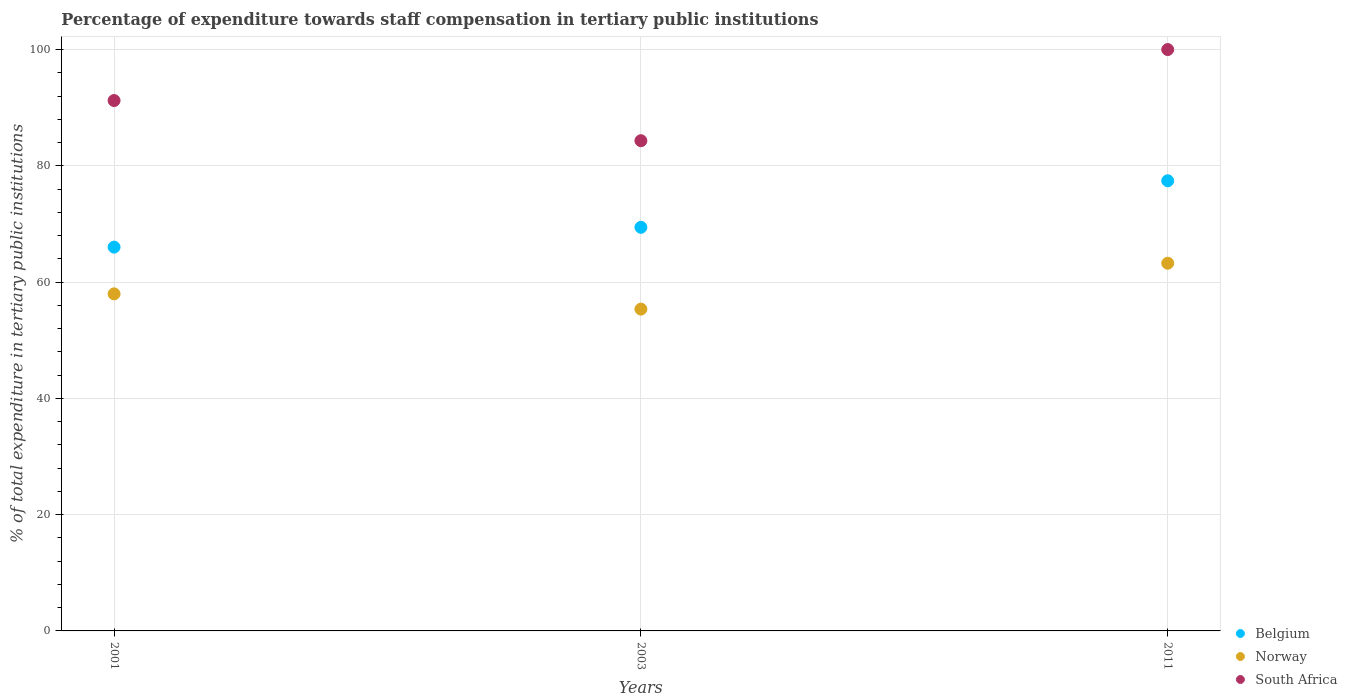How many different coloured dotlines are there?
Ensure brevity in your answer.  3. Is the number of dotlines equal to the number of legend labels?
Offer a terse response. Yes. What is the percentage of expenditure towards staff compensation in South Africa in 2003?
Give a very brief answer. 84.32. Across all years, what is the maximum percentage of expenditure towards staff compensation in Norway?
Your answer should be very brief. 63.25. Across all years, what is the minimum percentage of expenditure towards staff compensation in Belgium?
Make the answer very short. 66.02. In which year was the percentage of expenditure towards staff compensation in Belgium maximum?
Make the answer very short. 2011. What is the total percentage of expenditure towards staff compensation in Norway in the graph?
Make the answer very short. 176.58. What is the difference between the percentage of expenditure towards staff compensation in Norway in 2001 and that in 2003?
Give a very brief answer. 2.62. What is the difference between the percentage of expenditure towards staff compensation in South Africa in 2003 and the percentage of expenditure towards staff compensation in Belgium in 2001?
Ensure brevity in your answer.  18.3. What is the average percentage of expenditure towards staff compensation in South Africa per year?
Keep it short and to the point. 91.85. In the year 2001, what is the difference between the percentage of expenditure towards staff compensation in Norway and percentage of expenditure towards staff compensation in South Africa?
Offer a very short reply. -33.26. In how many years, is the percentage of expenditure towards staff compensation in Belgium greater than 96 %?
Your answer should be compact. 0. What is the ratio of the percentage of expenditure towards staff compensation in South Africa in 2003 to that in 2011?
Your answer should be very brief. 0.84. What is the difference between the highest and the second highest percentage of expenditure towards staff compensation in South Africa?
Keep it short and to the point. 8.77. What is the difference between the highest and the lowest percentage of expenditure towards staff compensation in Belgium?
Provide a succinct answer. 11.41. In how many years, is the percentage of expenditure towards staff compensation in South Africa greater than the average percentage of expenditure towards staff compensation in South Africa taken over all years?
Ensure brevity in your answer.  1. Is the sum of the percentage of expenditure towards staff compensation in Norway in 2001 and 2003 greater than the maximum percentage of expenditure towards staff compensation in South Africa across all years?
Give a very brief answer. Yes. Does the percentage of expenditure towards staff compensation in Belgium monotonically increase over the years?
Make the answer very short. Yes. Is the percentage of expenditure towards staff compensation in Belgium strictly greater than the percentage of expenditure towards staff compensation in Norway over the years?
Provide a succinct answer. Yes. How many years are there in the graph?
Keep it short and to the point. 3. What is the difference between two consecutive major ticks on the Y-axis?
Make the answer very short. 20. Does the graph contain any zero values?
Your answer should be very brief. No. Does the graph contain grids?
Make the answer very short. Yes. What is the title of the graph?
Keep it short and to the point. Percentage of expenditure towards staff compensation in tertiary public institutions. Does "Tajikistan" appear as one of the legend labels in the graph?
Offer a terse response. No. What is the label or title of the Y-axis?
Offer a terse response. % of total expenditure in tertiary public institutions. What is the % of total expenditure in tertiary public institutions in Belgium in 2001?
Offer a terse response. 66.02. What is the % of total expenditure in tertiary public institutions of Norway in 2001?
Your response must be concise. 57.97. What is the % of total expenditure in tertiary public institutions of South Africa in 2001?
Provide a short and direct response. 91.23. What is the % of total expenditure in tertiary public institutions of Belgium in 2003?
Your answer should be very brief. 69.43. What is the % of total expenditure in tertiary public institutions of Norway in 2003?
Give a very brief answer. 55.36. What is the % of total expenditure in tertiary public institutions in South Africa in 2003?
Your answer should be compact. 84.32. What is the % of total expenditure in tertiary public institutions of Belgium in 2011?
Ensure brevity in your answer.  77.43. What is the % of total expenditure in tertiary public institutions of Norway in 2011?
Give a very brief answer. 63.25. Across all years, what is the maximum % of total expenditure in tertiary public institutions in Belgium?
Offer a terse response. 77.43. Across all years, what is the maximum % of total expenditure in tertiary public institutions in Norway?
Ensure brevity in your answer.  63.25. Across all years, what is the maximum % of total expenditure in tertiary public institutions of South Africa?
Keep it short and to the point. 100. Across all years, what is the minimum % of total expenditure in tertiary public institutions of Belgium?
Your answer should be very brief. 66.02. Across all years, what is the minimum % of total expenditure in tertiary public institutions in Norway?
Provide a succinct answer. 55.36. Across all years, what is the minimum % of total expenditure in tertiary public institutions of South Africa?
Provide a succinct answer. 84.32. What is the total % of total expenditure in tertiary public institutions in Belgium in the graph?
Give a very brief answer. 212.87. What is the total % of total expenditure in tertiary public institutions of Norway in the graph?
Your answer should be very brief. 176.58. What is the total % of total expenditure in tertiary public institutions in South Africa in the graph?
Offer a terse response. 275.55. What is the difference between the % of total expenditure in tertiary public institutions in Belgium in 2001 and that in 2003?
Keep it short and to the point. -3.41. What is the difference between the % of total expenditure in tertiary public institutions in Norway in 2001 and that in 2003?
Offer a very short reply. 2.62. What is the difference between the % of total expenditure in tertiary public institutions of South Africa in 2001 and that in 2003?
Provide a succinct answer. 6.91. What is the difference between the % of total expenditure in tertiary public institutions in Belgium in 2001 and that in 2011?
Your answer should be very brief. -11.41. What is the difference between the % of total expenditure in tertiary public institutions in Norway in 2001 and that in 2011?
Make the answer very short. -5.27. What is the difference between the % of total expenditure in tertiary public institutions of South Africa in 2001 and that in 2011?
Your answer should be very brief. -8.77. What is the difference between the % of total expenditure in tertiary public institutions of Belgium in 2003 and that in 2011?
Make the answer very short. -8. What is the difference between the % of total expenditure in tertiary public institutions in Norway in 2003 and that in 2011?
Provide a short and direct response. -7.89. What is the difference between the % of total expenditure in tertiary public institutions in South Africa in 2003 and that in 2011?
Offer a very short reply. -15.68. What is the difference between the % of total expenditure in tertiary public institutions of Belgium in 2001 and the % of total expenditure in tertiary public institutions of Norway in 2003?
Your response must be concise. 10.66. What is the difference between the % of total expenditure in tertiary public institutions in Belgium in 2001 and the % of total expenditure in tertiary public institutions in South Africa in 2003?
Give a very brief answer. -18.3. What is the difference between the % of total expenditure in tertiary public institutions of Norway in 2001 and the % of total expenditure in tertiary public institutions of South Africa in 2003?
Your response must be concise. -26.35. What is the difference between the % of total expenditure in tertiary public institutions in Belgium in 2001 and the % of total expenditure in tertiary public institutions in Norway in 2011?
Offer a terse response. 2.77. What is the difference between the % of total expenditure in tertiary public institutions of Belgium in 2001 and the % of total expenditure in tertiary public institutions of South Africa in 2011?
Your answer should be very brief. -33.98. What is the difference between the % of total expenditure in tertiary public institutions in Norway in 2001 and the % of total expenditure in tertiary public institutions in South Africa in 2011?
Offer a terse response. -42.03. What is the difference between the % of total expenditure in tertiary public institutions in Belgium in 2003 and the % of total expenditure in tertiary public institutions in Norway in 2011?
Make the answer very short. 6.18. What is the difference between the % of total expenditure in tertiary public institutions in Belgium in 2003 and the % of total expenditure in tertiary public institutions in South Africa in 2011?
Provide a succinct answer. -30.57. What is the difference between the % of total expenditure in tertiary public institutions in Norway in 2003 and the % of total expenditure in tertiary public institutions in South Africa in 2011?
Keep it short and to the point. -44.64. What is the average % of total expenditure in tertiary public institutions in Belgium per year?
Make the answer very short. 70.96. What is the average % of total expenditure in tertiary public institutions of Norway per year?
Offer a terse response. 58.86. What is the average % of total expenditure in tertiary public institutions in South Africa per year?
Ensure brevity in your answer.  91.85. In the year 2001, what is the difference between the % of total expenditure in tertiary public institutions in Belgium and % of total expenditure in tertiary public institutions in Norway?
Your response must be concise. 8.04. In the year 2001, what is the difference between the % of total expenditure in tertiary public institutions in Belgium and % of total expenditure in tertiary public institutions in South Africa?
Ensure brevity in your answer.  -25.21. In the year 2001, what is the difference between the % of total expenditure in tertiary public institutions in Norway and % of total expenditure in tertiary public institutions in South Africa?
Your response must be concise. -33.26. In the year 2003, what is the difference between the % of total expenditure in tertiary public institutions of Belgium and % of total expenditure in tertiary public institutions of Norway?
Keep it short and to the point. 14.07. In the year 2003, what is the difference between the % of total expenditure in tertiary public institutions of Belgium and % of total expenditure in tertiary public institutions of South Africa?
Your response must be concise. -14.89. In the year 2003, what is the difference between the % of total expenditure in tertiary public institutions of Norway and % of total expenditure in tertiary public institutions of South Africa?
Provide a short and direct response. -28.96. In the year 2011, what is the difference between the % of total expenditure in tertiary public institutions of Belgium and % of total expenditure in tertiary public institutions of Norway?
Ensure brevity in your answer.  14.18. In the year 2011, what is the difference between the % of total expenditure in tertiary public institutions in Belgium and % of total expenditure in tertiary public institutions in South Africa?
Your answer should be very brief. -22.57. In the year 2011, what is the difference between the % of total expenditure in tertiary public institutions in Norway and % of total expenditure in tertiary public institutions in South Africa?
Provide a short and direct response. -36.75. What is the ratio of the % of total expenditure in tertiary public institutions in Belgium in 2001 to that in 2003?
Ensure brevity in your answer.  0.95. What is the ratio of the % of total expenditure in tertiary public institutions of Norway in 2001 to that in 2003?
Keep it short and to the point. 1.05. What is the ratio of the % of total expenditure in tertiary public institutions in South Africa in 2001 to that in 2003?
Your answer should be compact. 1.08. What is the ratio of the % of total expenditure in tertiary public institutions of Belgium in 2001 to that in 2011?
Ensure brevity in your answer.  0.85. What is the ratio of the % of total expenditure in tertiary public institutions in Norway in 2001 to that in 2011?
Your response must be concise. 0.92. What is the ratio of the % of total expenditure in tertiary public institutions in South Africa in 2001 to that in 2011?
Offer a terse response. 0.91. What is the ratio of the % of total expenditure in tertiary public institutions in Belgium in 2003 to that in 2011?
Your response must be concise. 0.9. What is the ratio of the % of total expenditure in tertiary public institutions of Norway in 2003 to that in 2011?
Your answer should be compact. 0.88. What is the ratio of the % of total expenditure in tertiary public institutions of South Africa in 2003 to that in 2011?
Keep it short and to the point. 0.84. What is the difference between the highest and the second highest % of total expenditure in tertiary public institutions of Belgium?
Your answer should be compact. 8. What is the difference between the highest and the second highest % of total expenditure in tertiary public institutions in Norway?
Your answer should be compact. 5.27. What is the difference between the highest and the second highest % of total expenditure in tertiary public institutions of South Africa?
Your response must be concise. 8.77. What is the difference between the highest and the lowest % of total expenditure in tertiary public institutions in Belgium?
Ensure brevity in your answer.  11.41. What is the difference between the highest and the lowest % of total expenditure in tertiary public institutions of Norway?
Ensure brevity in your answer.  7.89. What is the difference between the highest and the lowest % of total expenditure in tertiary public institutions in South Africa?
Make the answer very short. 15.68. 